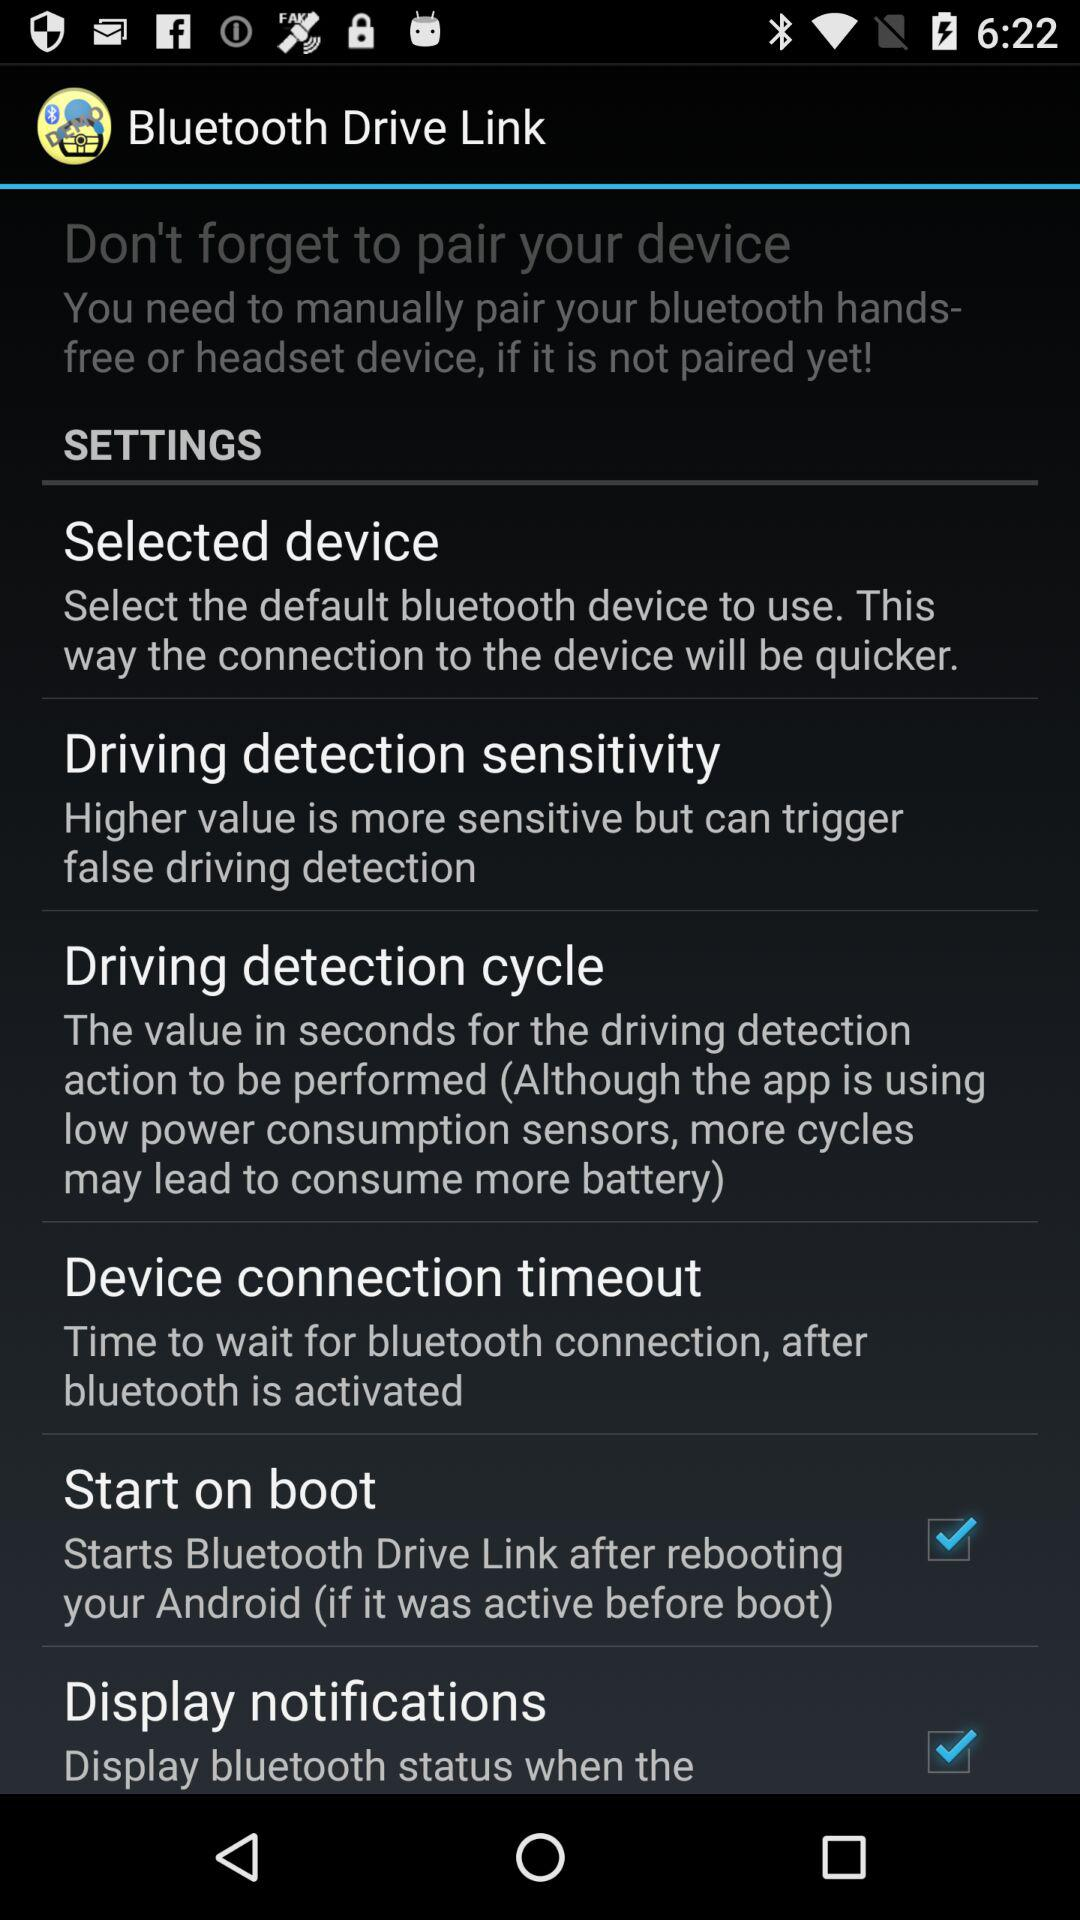How to connect device connection?
When the provided information is insufficient, respond with <no answer>. <no answer> 